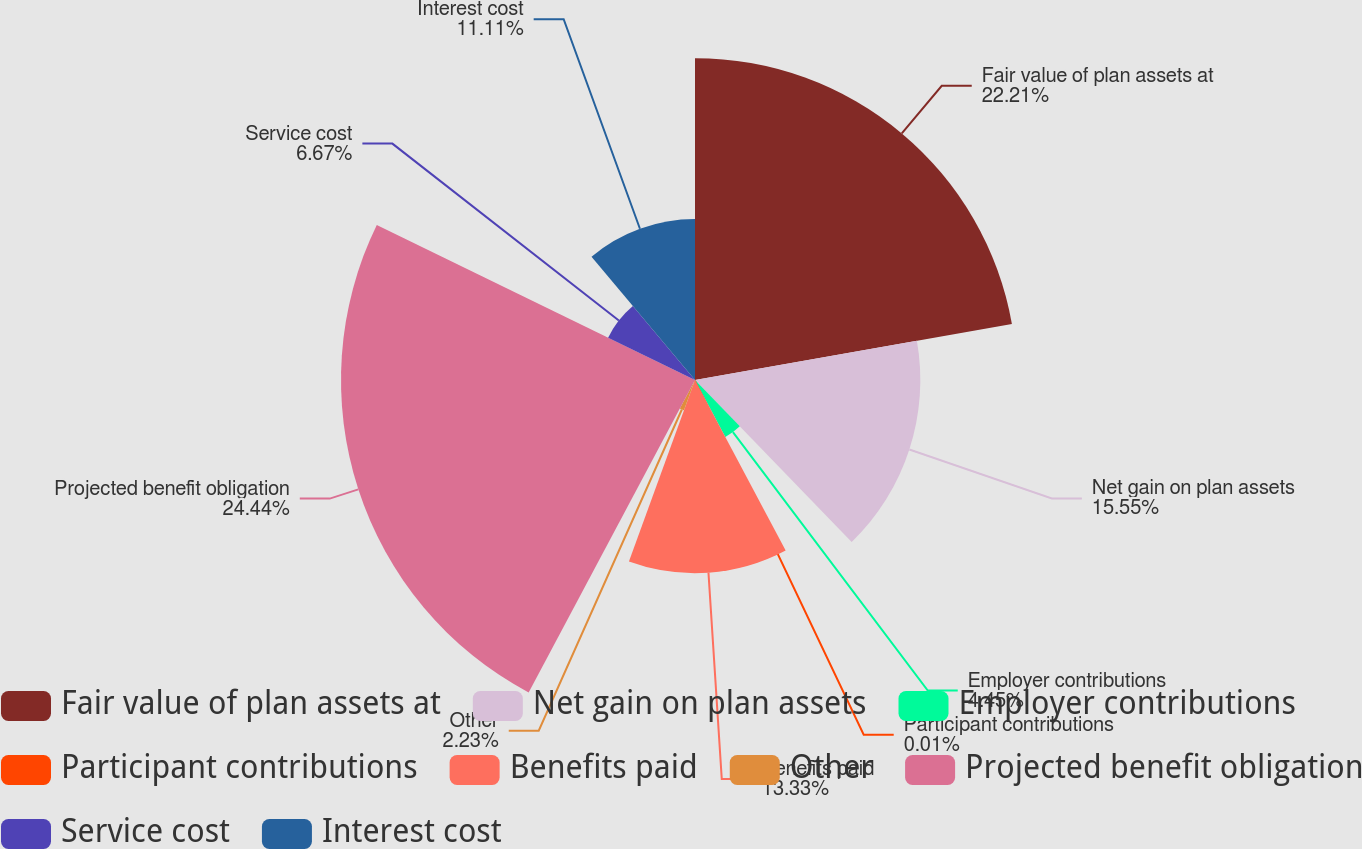Convert chart to OTSL. <chart><loc_0><loc_0><loc_500><loc_500><pie_chart><fcel>Fair value of plan assets at<fcel>Net gain on plan assets<fcel>Employer contributions<fcel>Participant contributions<fcel>Benefits paid<fcel>Other<fcel>Projected benefit obligation<fcel>Service cost<fcel>Interest cost<nl><fcel>22.21%<fcel>15.55%<fcel>4.45%<fcel>0.01%<fcel>13.33%<fcel>2.23%<fcel>24.43%<fcel>6.67%<fcel>11.11%<nl></chart> 